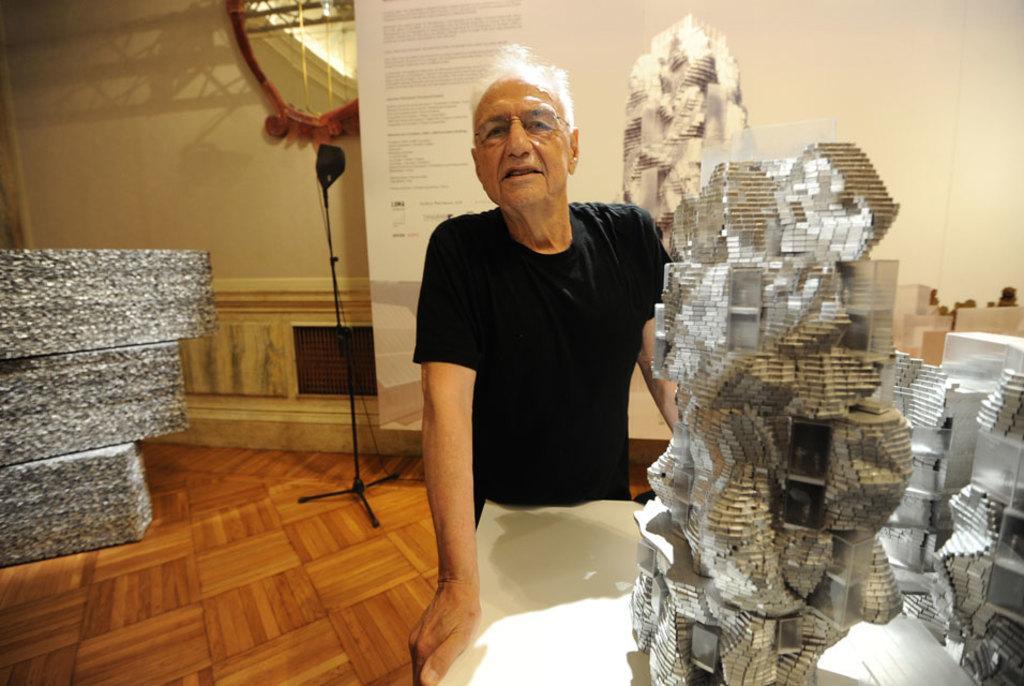Could you give a brief overview of what you see in this image? In this image we can see a person standing in a room and holding a table and there are some objects on the table, in the background there is a stand and a banner with text and on the left side there are some objects. 